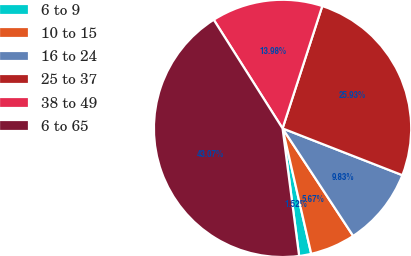<chart> <loc_0><loc_0><loc_500><loc_500><pie_chart><fcel>6 to 9<fcel>10 to 15<fcel>16 to 24<fcel>25 to 37<fcel>38 to 49<fcel>6 to 65<nl><fcel>1.52%<fcel>5.67%<fcel>9.83%<fcel>25.93%<fcel>13.98%<fcel>43.07%<nl></chart> 